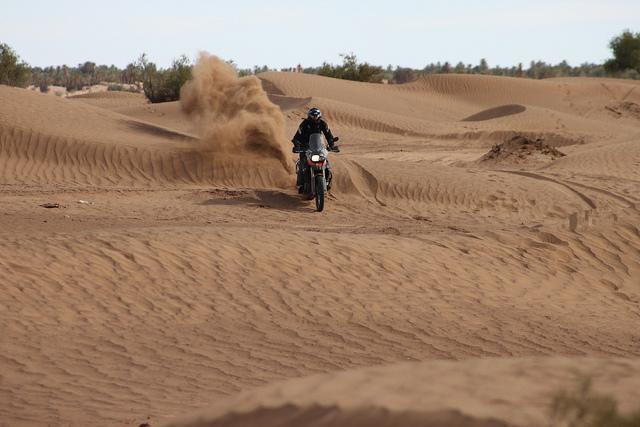How many trucks are shown?
Give a very brief answer. 0. 